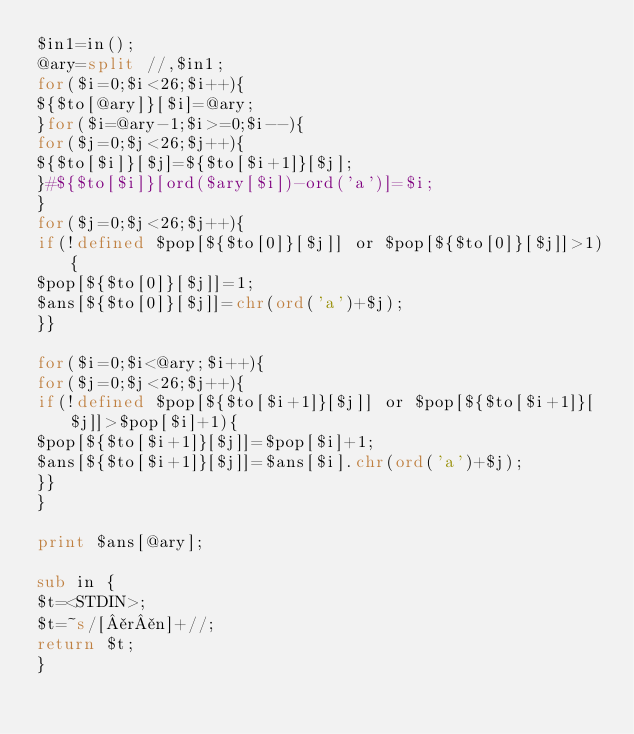<code> <loc_0><loc_0><loc_500><loc_500><_Perl_>$in1=in();
@ary=split //,$in1;
for($i=0;$i<26;$i++){
${$to[@ary]}[$i]=@ary;
}for($i=@ary-1;$i>=0;$i--){
for($j=0;$j<26;$j++){
${$to[$i]}[$j]=${$to[$i+1]}[$j];
}#${$to[$i]}[ord($ary[$i])-ord('a')]=$i;
}
for($j=0;$j<26;$j++){
if(!defined $pop[${$to[0]}[$j]] or $pop[${$to[0]}[$j]]>1){
$pop[${$to[0]}[$j]]=1;
$ans[${$to[0]}[$j]]=chr(ord('a')+$j);
}}

for($i=0;$i<@ary;$i++){
for($j=0;$j<26;$j++){
if(!defined $pop[${$to[$i+1]}[$j]] or $pop[${$to[$i+1]}[$j]]>$pop[$i]+1){
$pop[${$to[$i+1]}[$j]]=$pop[$i]+1;
$ans[${$to[$i+1]}[$j]]=$ans[$i].chr(ord('a')+$j);
}}
}

print $ans[@ary];

sub in {
$t=<STDIN>;
$t=~s/[¥r¥n]+//;
return $t;
}
</code> 